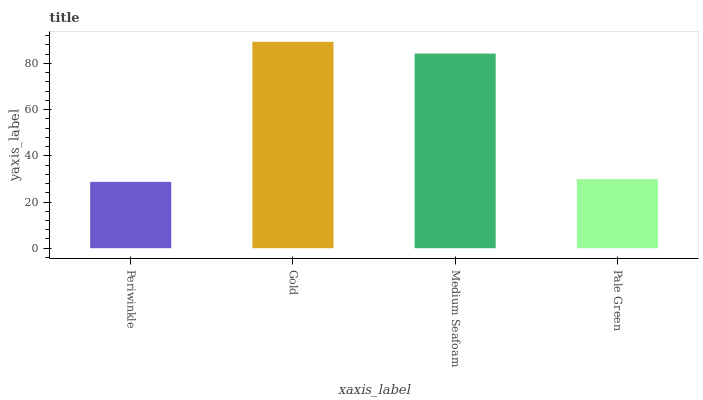Is Periwinkle the minimum?
Answer yes or no. Yes. Is Gold the maximum?
Answer yes or no. Yes. Is Medium Seafoam the minimum?
Answer yes or no. No. Is Medium Seafoam the maximum?
Answer yes or no. No. Is Gold greater than Medium Seafoam?
Answer yes or no. Yes. Is Medium Seafoam less than Gold?
Answer yes or no. Yes. Is Medium Seafoam greater than Gold?
Answer yes or no. No. Is Gold less than Medium Seafoam?
Answer yes or no. No. Is Medium Seafoam the high median?
Answer yes or no. Yes. Is Pale Green the low median?
Answer yes or no. Yes. Is Pale Green the high median?
Answer yes or no. No. Is Periwinkle the low median?
Answer yes or no. No. 